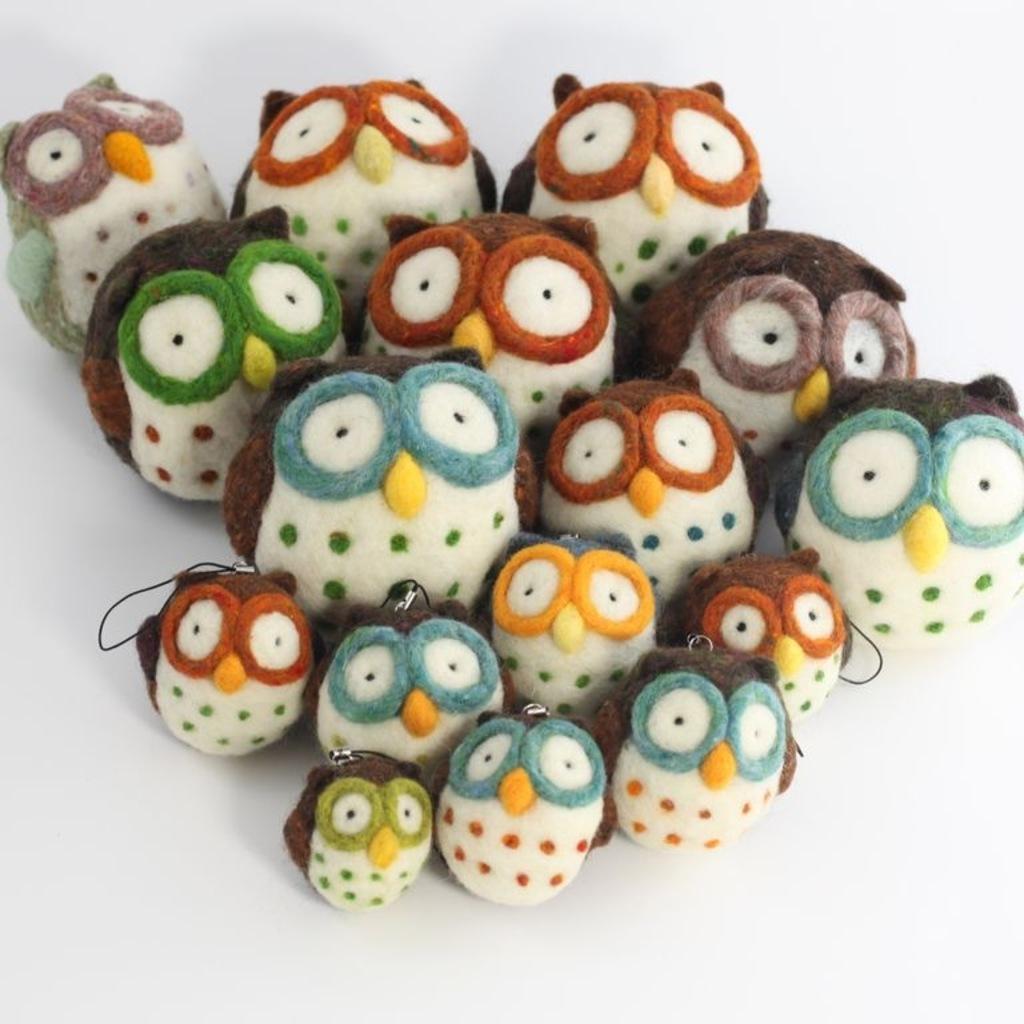Could you give a brief overview of what you see in this image? In this image we can see some owl toys on the white surface. 